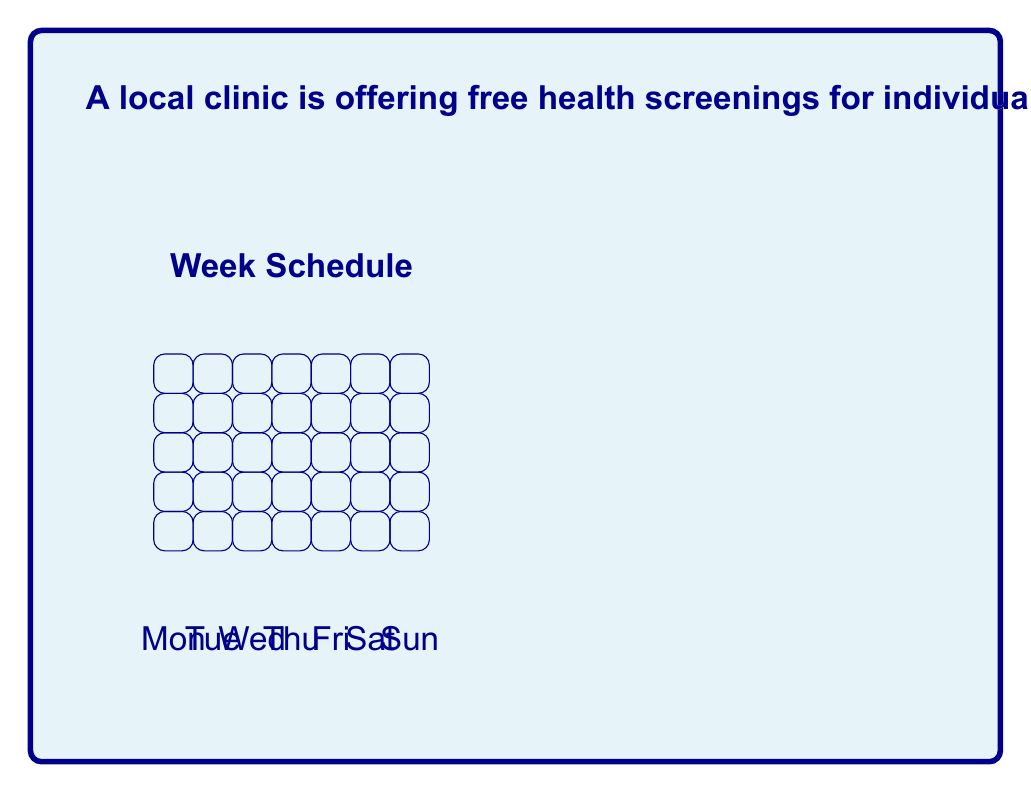Can you answer this question? Let's approach this step-by-step:

1) First, we need to determine how many ways we can choose 3 days out of 7 for the appointments. This is a combination problem, denoted as $\binom{7}{3}$.

   $\binom{7}{3} = \frac{7!}{3!(7-3)!} = \frac{7!}{3!4!} = 35$

2) For each of these 35 ways of choosing 3 days, we need to consider the number of ways to arrange the appointments within those days. This is a permutation of 3, which is simply $3! = 3 \times 2 \times 1 = 6$.

3) For each day, we have 5 possible appointment slots to choose from. Since we're scheduling 3 appointments, we multiply by 5 three times:

   $5 \times 5 \times 5 = 5^3 = 125$

4) By the multiplication principle, we multiply all these factors together:

   $35 \times 6 \times 125 = 26,250$

Therefore, there are 26,250 unique ways to schedule 3 appointments within the week.
Answer: 26,250 